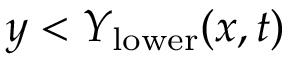Convert formula to latex. <formula><loc_0><loc_0><loc_500><loc_500>y < Y _ { l o w e r } ( x , t )</formula> 